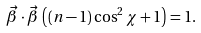Convert formula to latex. <formula><loc_0><loc_0><loc_500><loc_500>\vec { \beta } \cdot \vec { \beta } \, \left ( ( n - 1 ) \cos ^ { 2 } \chi + 1 \right ) = 1 .</formula> 